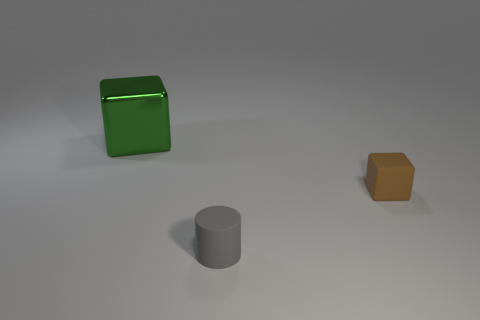Add 2 tiny things. How many objects exist? 5 Subtract all cubes. How many objects are left? 1 Add 2 tiny brown blocks. How many tiny brown blocks are left? 3 Add 2 big blocks. How many big blocks exist? 3 Subtract all brown cubes. How many cubes are left? 1 Subtract 0 green spheres. How many objects are left? 3 Subtract 1 cylinders. How many cylinders are left? 0 Subtract all purple cubes. Subtract all green cylinders. How many cubes are left? 2 Subtract all purple cylinders. How many green cubes are left? 1 Subtract all tiny brown metal cylinders. Subtract all brown blocks. How many objects are left? 2 